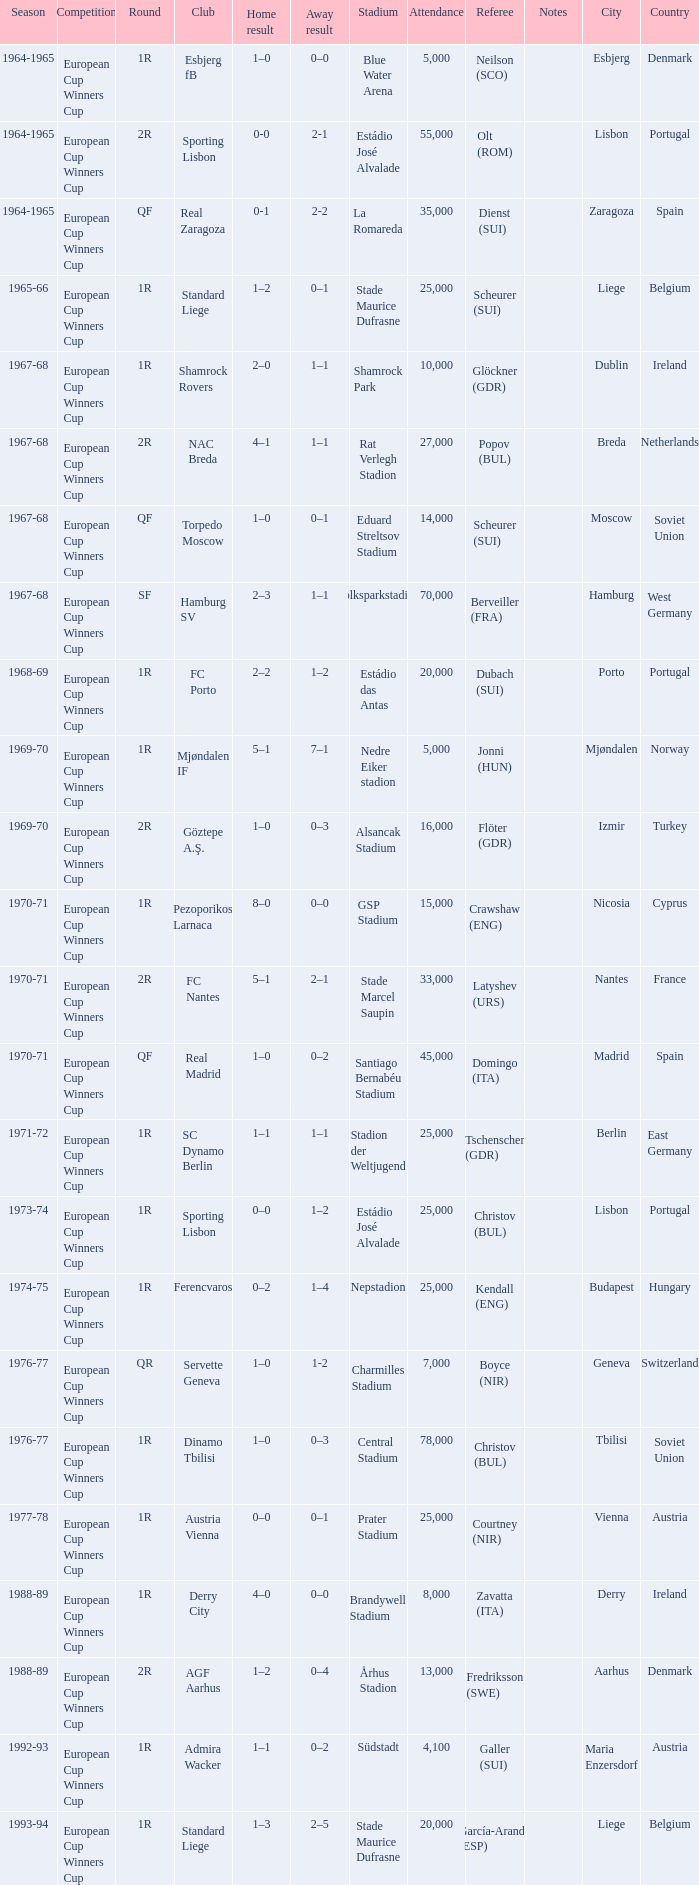Away result of 1–1, and a Round of 1r, and a Season of 1967-68 involves what club? Shamrock Rovers. 